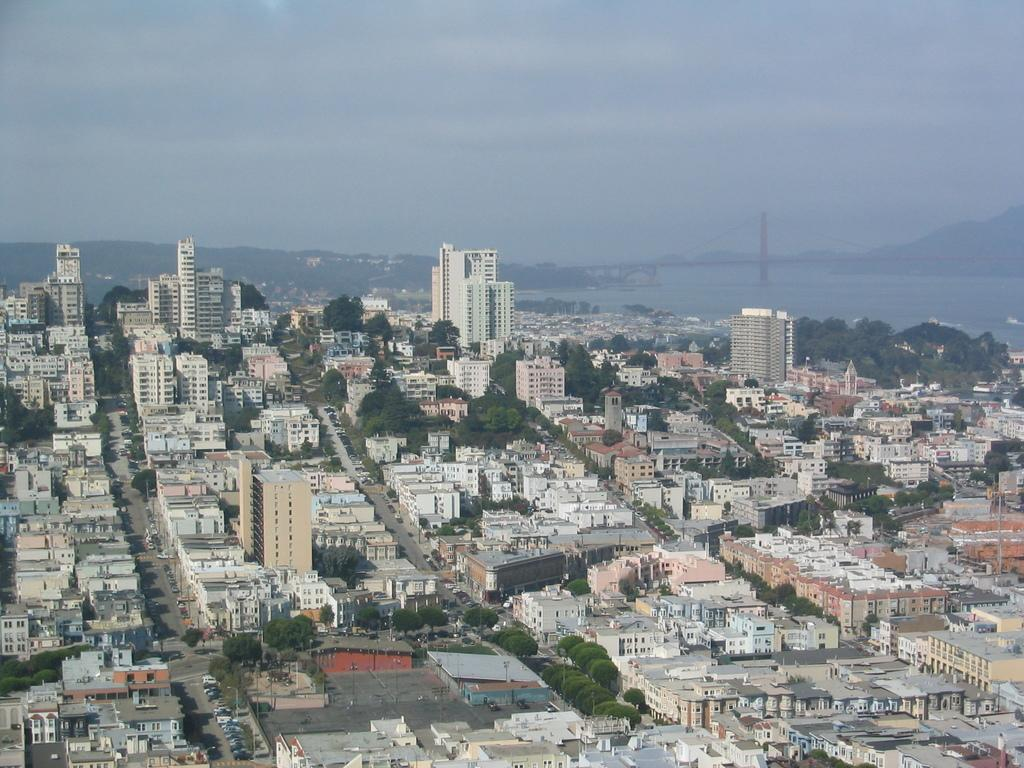What type of structures can be seen in the image? There are buildings in the image. What other natural elements are present in the image? There are trees in the image. What is visible at the top of the image? The sky is visible at the top of the image. What type of breakfast is being served on the river in the image? There is no river or breakfast present in the image; it features buildings, trees, and the sky. What color is the sweater worn by the person in the image? There is no person or sweater present in the image. 